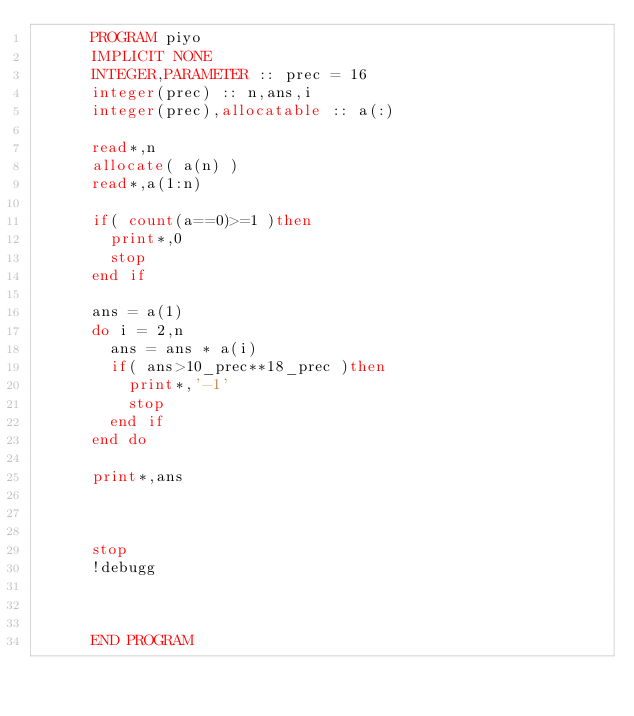Convert code to text. <code><loc_0><loc_0><loc_500><loc_500><_FORTRAN_>      PROGRAM piyo
      IMPLICIT NONE
      INTEGER,PARAMETER :: prec = 16
      integer(prec) :: n,ans,i
      integer(prec),allocatable :: a(:)
      
      read*,n
      allocate( a(n) )
      read*,a(1:n)
      
      if( count(a==0)>=1 )then
        print*,0
        stop
      end if
      
      ans = a(1)
      do i = 2,n
        ans = ans * a(i)
        if( ans>10_prec**18_prec )then
          print*,'-1'
          stop
        end if
      end do
      
      print*,ans
      
      
      
      stop
      !debugg
      
      
      
      END PROGRAM</code> 